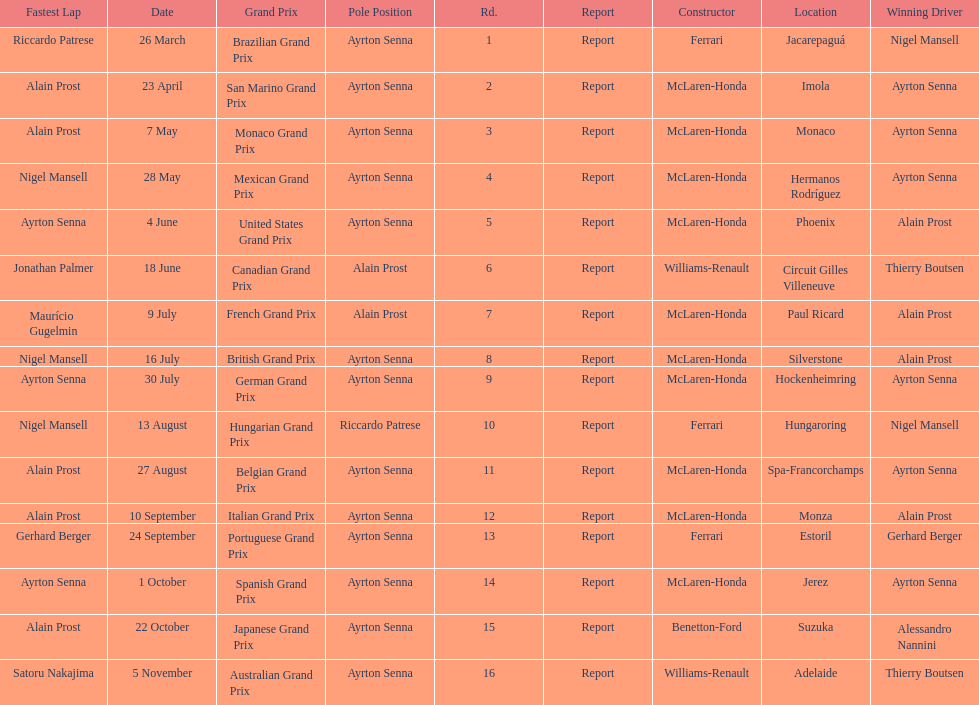Who are the constructors in the 1989 formula one season? Ferrari, McLaren-Honda, McLaren-Honda, McLaren-Honda, McLaren-Honda, Williams-Renault, McLaren-Honda, McLaren-Honda, McLaren-Honda, Ferrari, McLaren-Honda, McLaren-Honda, Ferrari, McLaren-Honda, Benetton-Ford, Williams-Renault. On what date was bennington ford the constructor? 22 October. What was the race on october 22? Japanese Grand Prix. 